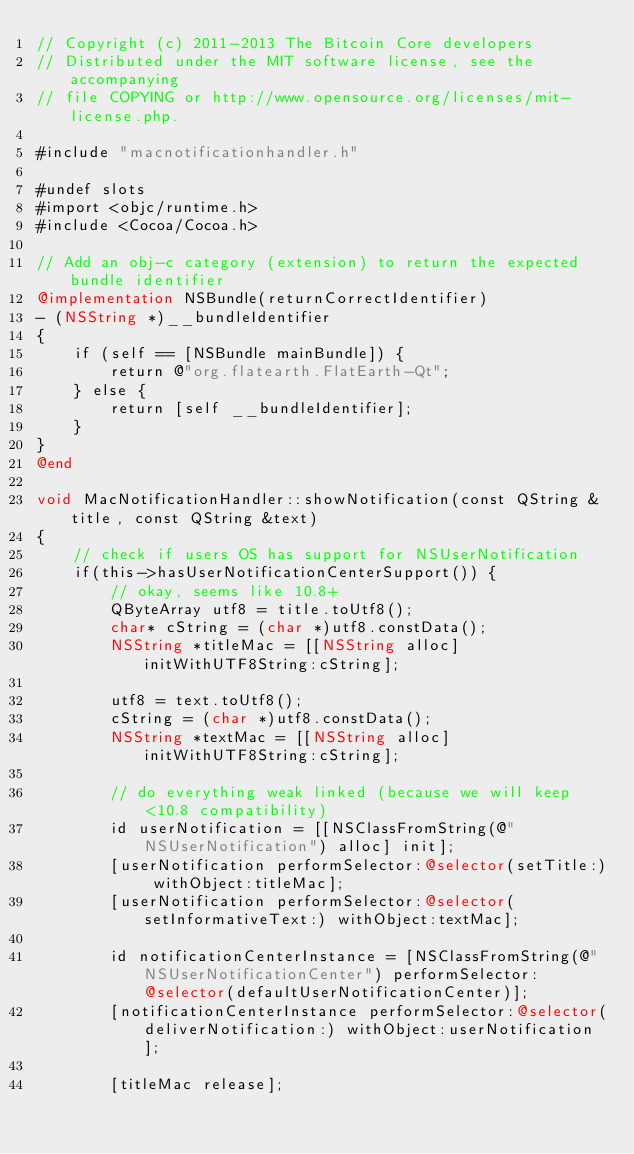<code> <loc_0><loc_0><loc_500><loc_500><_ObjectiveC_>// Copyright (c) 2011-2013 The Bitcoin Core developers
// Distributed under the MIT software license, see the accompanying
// file COPYING or http://www.opensource.org/licenses/mit-license.php.

#include "macnotificationhandler.h"

#undef slots
#import <objc/runtime.h>
#include <Cocoa/Cocoa.h>

// Add an obj-c category (extension) to return the expected bundle identifier
@implementation NSBundle(returnCorrectIdentifier)
- (NSString *)__bundleIdentifier
{
    if (self == [NSBundle mainBundle]) {
        return @"org.flatearth.FlatEarth-Qt";
    } else {
        return [self __bundleIdentifier];
    }
}
@end

void MacNotificationHandler::showNotification(const QString &title, const QString &text)
{
    // check if users OS has support for NSUserNotification
    if(this->hasUserNotificationCenterSupport()) {
        // okay, seems like 10.8+
        QByteArray utf8 = title.toUtf8();
        char* cString = (char *)utf8.constData();
        NSString *titleMac = [[NSString alloc] initWithUTF8String:cString];

        utf8 = text.toUtf8();
        cString = (char *)utf8.constData();
        NSString *textMac = [[NSString alloc] initWithUTF8String:cString];

        // do everything weak linked (because we will keep <10.8 compatibility)
        id userNotification = [[NSClassFromString(@"NSUserNotification") alloc] init];
        [userNotification performSelector:@selector(setTitle:) withObject:titleMac];
        [userNotification performSelector:@selector(setInformativeText:) withObject:textMac];

        id notificationCenterInstance = [NSClassFromString(@"NSUserNotificationCenter") performSelector:@selector(defaultUserNotificationCenter)];
        [notificationCenterInstance performSelector:@selector(deliverNotification:) withObject:userNotification];

        [titleMac release];</code> 